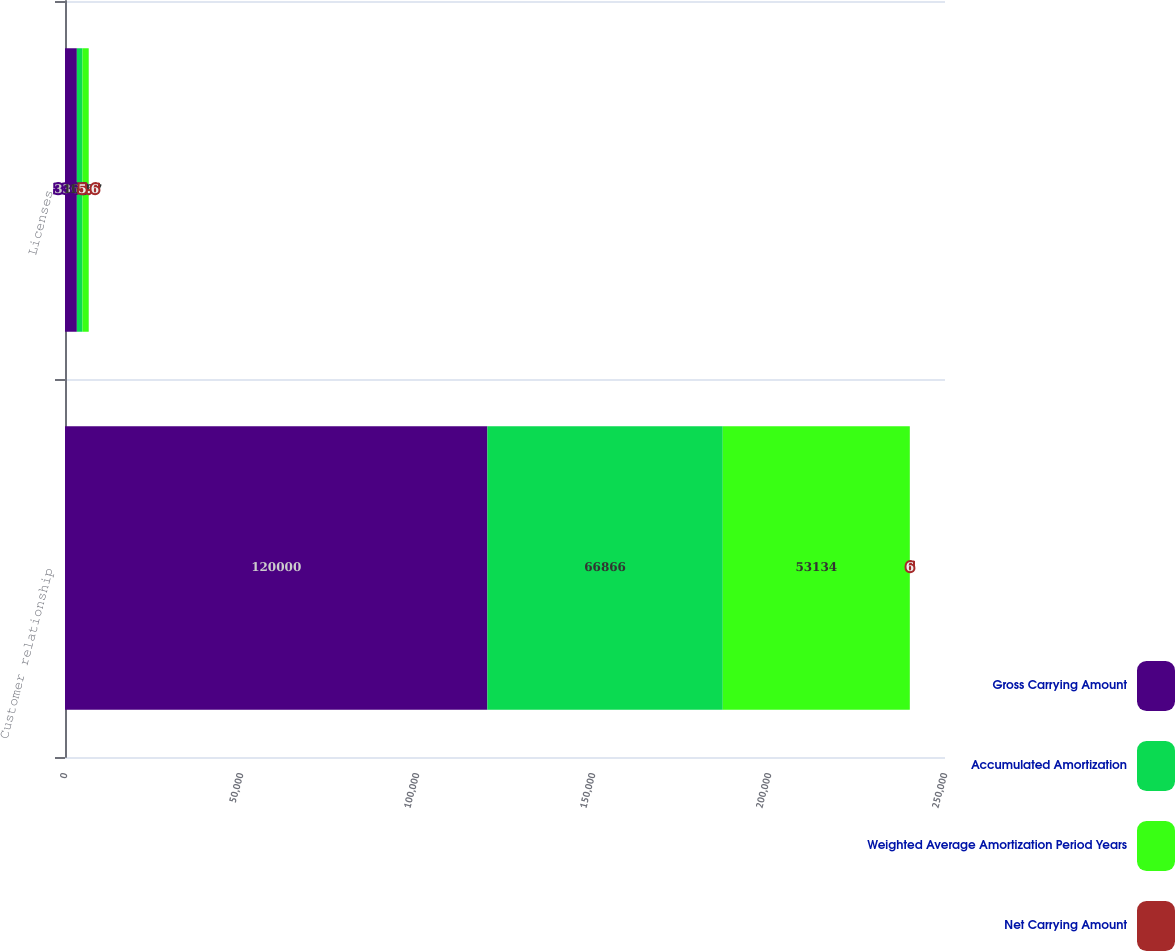<chart> <loc_0><loc_0><loc_500><loc_500><stacked_bar_chart><ecel><fcel>Customer relationship<fcel>Licenses<nl><fcel>Gross Carrying Amount<fcel>120000<fcel>3368<nl><fcel>Accumulated Amortization<fcel>66866<fcel>1601<nl><fcel>Weighted Average Amortization Period Years<fcel>53134<fcel>1767<nl><fcel>Net Carrying Amount<fcel>6<fcel>5.6<nl></chart> 